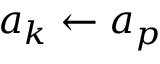Convert formula to latex. <formula><loc_0><loc_0><loc_500><loc_500>a _ { k } \leftarrow a _ { p }</formula> 